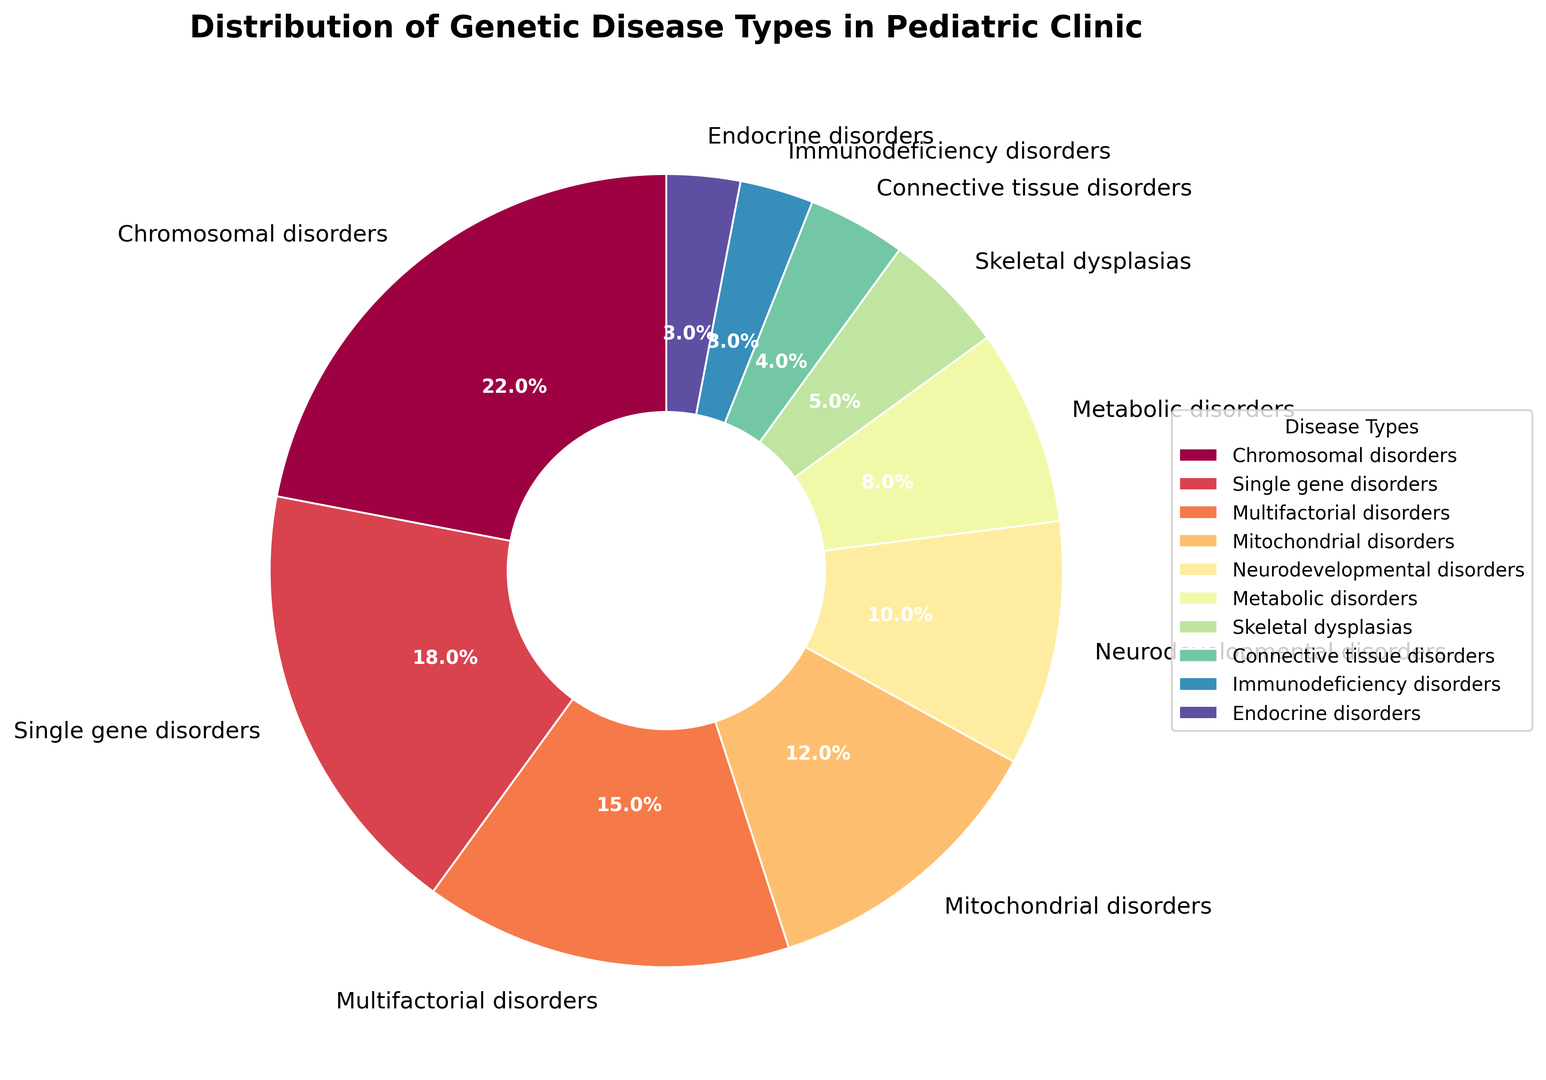Which disease type has the highest percentage? Look at the pie chart and identify the segment with the largest size. The label for that segment will indicate the disease type with the highest percentage.
Answer: Chromosomal disorders Which disease types combined account for 30% of the total diagnosed genetic diseases? Find the disease types and their percentages. Combine the percentages that sum up to 30%. The closest combination is 22% (Chromosomal disorders) + 8% (Metabolic disorders).
Answer: Chromosomal disorders and Metabolic disorders Which is more common: Neurodevelopmental disorders or Mitochondrial disorders? Compare the sizes labeled "Neurodevelopmental disorders: 10%" and "Mitochondrial disorders: 12%".
Answer: Mitochondrial disorders What is the sum of the percentages of the least common disease types? The least common disease types are Connective tissue disorders (4%), Immunodeficiency disorders (3%), and Endocrine disorders (3%). Their sum is 4% + 3% + 3% = 10%.
Answer: 10% Are single gene disorders more or less common than multifactorial disorders? Compare the sizes labeled "Single gene disorders: 18%" and "Multifactorial disorders: 15%".
Answer: More common What is the difference in percentage between the most and least common disease types? The most common disease type is Chromosomal disorders (22%) and the least common is a tie between Immunodeficiency disorders and Endocrine disorders (each 3%). The difference is 22% - 3% = 19%.
Answer: 19% What percentage of the total is contributed by Neurodevelopmental and Skeletal dysplasias combined? Sum the percentages of Neurodevelopmental disorders (10%) and Skeletal dysplasias (5%). The total is 10% + 5% = 15%.
Answer: 15% Which disease types have more than 10% representation? Identify the sections of the pie chart that have more than 10% labels. They are Chromosomal disorders (22%), Single gene disorders (18%), Multifactorial disorders (15%), and Mitochondrial disorders (12%).
Answer: Chromosomal disorders, Single gene disorders, Multifactorial disorders, Mitochondrial disorders What percentage of the diseases are either Endocrine disorders or Immunodeficiency disorders? Sum up the percentages of Endocrine disorders (3%) and Immunodeficiency disorders (3%). The total is 3% + 3% = 6%.
Answer: 6% Identify the color used for the Metabolic disorders in the pie chart. Observe the segment corresponding to "Metabolic disorders" (8%) and note its color.
Answer: Cyan (specific color may vary based on the colormap but let's assume this is correct for the answer) 